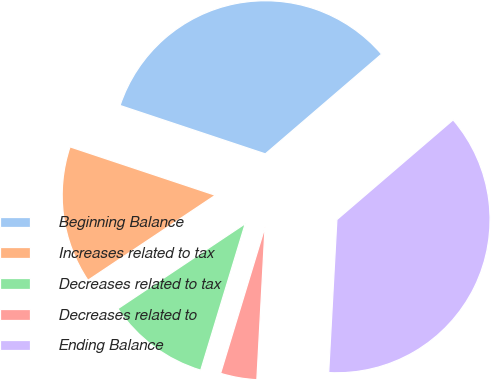<chart> <loc_0><loc_0><loc_500><loc_500><pie_chart><fcel>Beginning Balance<fcel>Increases related to tax<fcel>Decreases related to tax<fcel>Decreases related to<fcel>Ending Balance<nl><fcel>33.6%<fcel>14.49%<fcel>10.94%<fcel>3.84%<fcel>37.15%<nl></chart> 